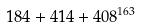Convert formula to latex. <formula><loc_0><loc_0><loc_500><loc_500>1 8 4 + 4 1 4 + 4 0 8 ^ { 1 6 3 }</formula> 